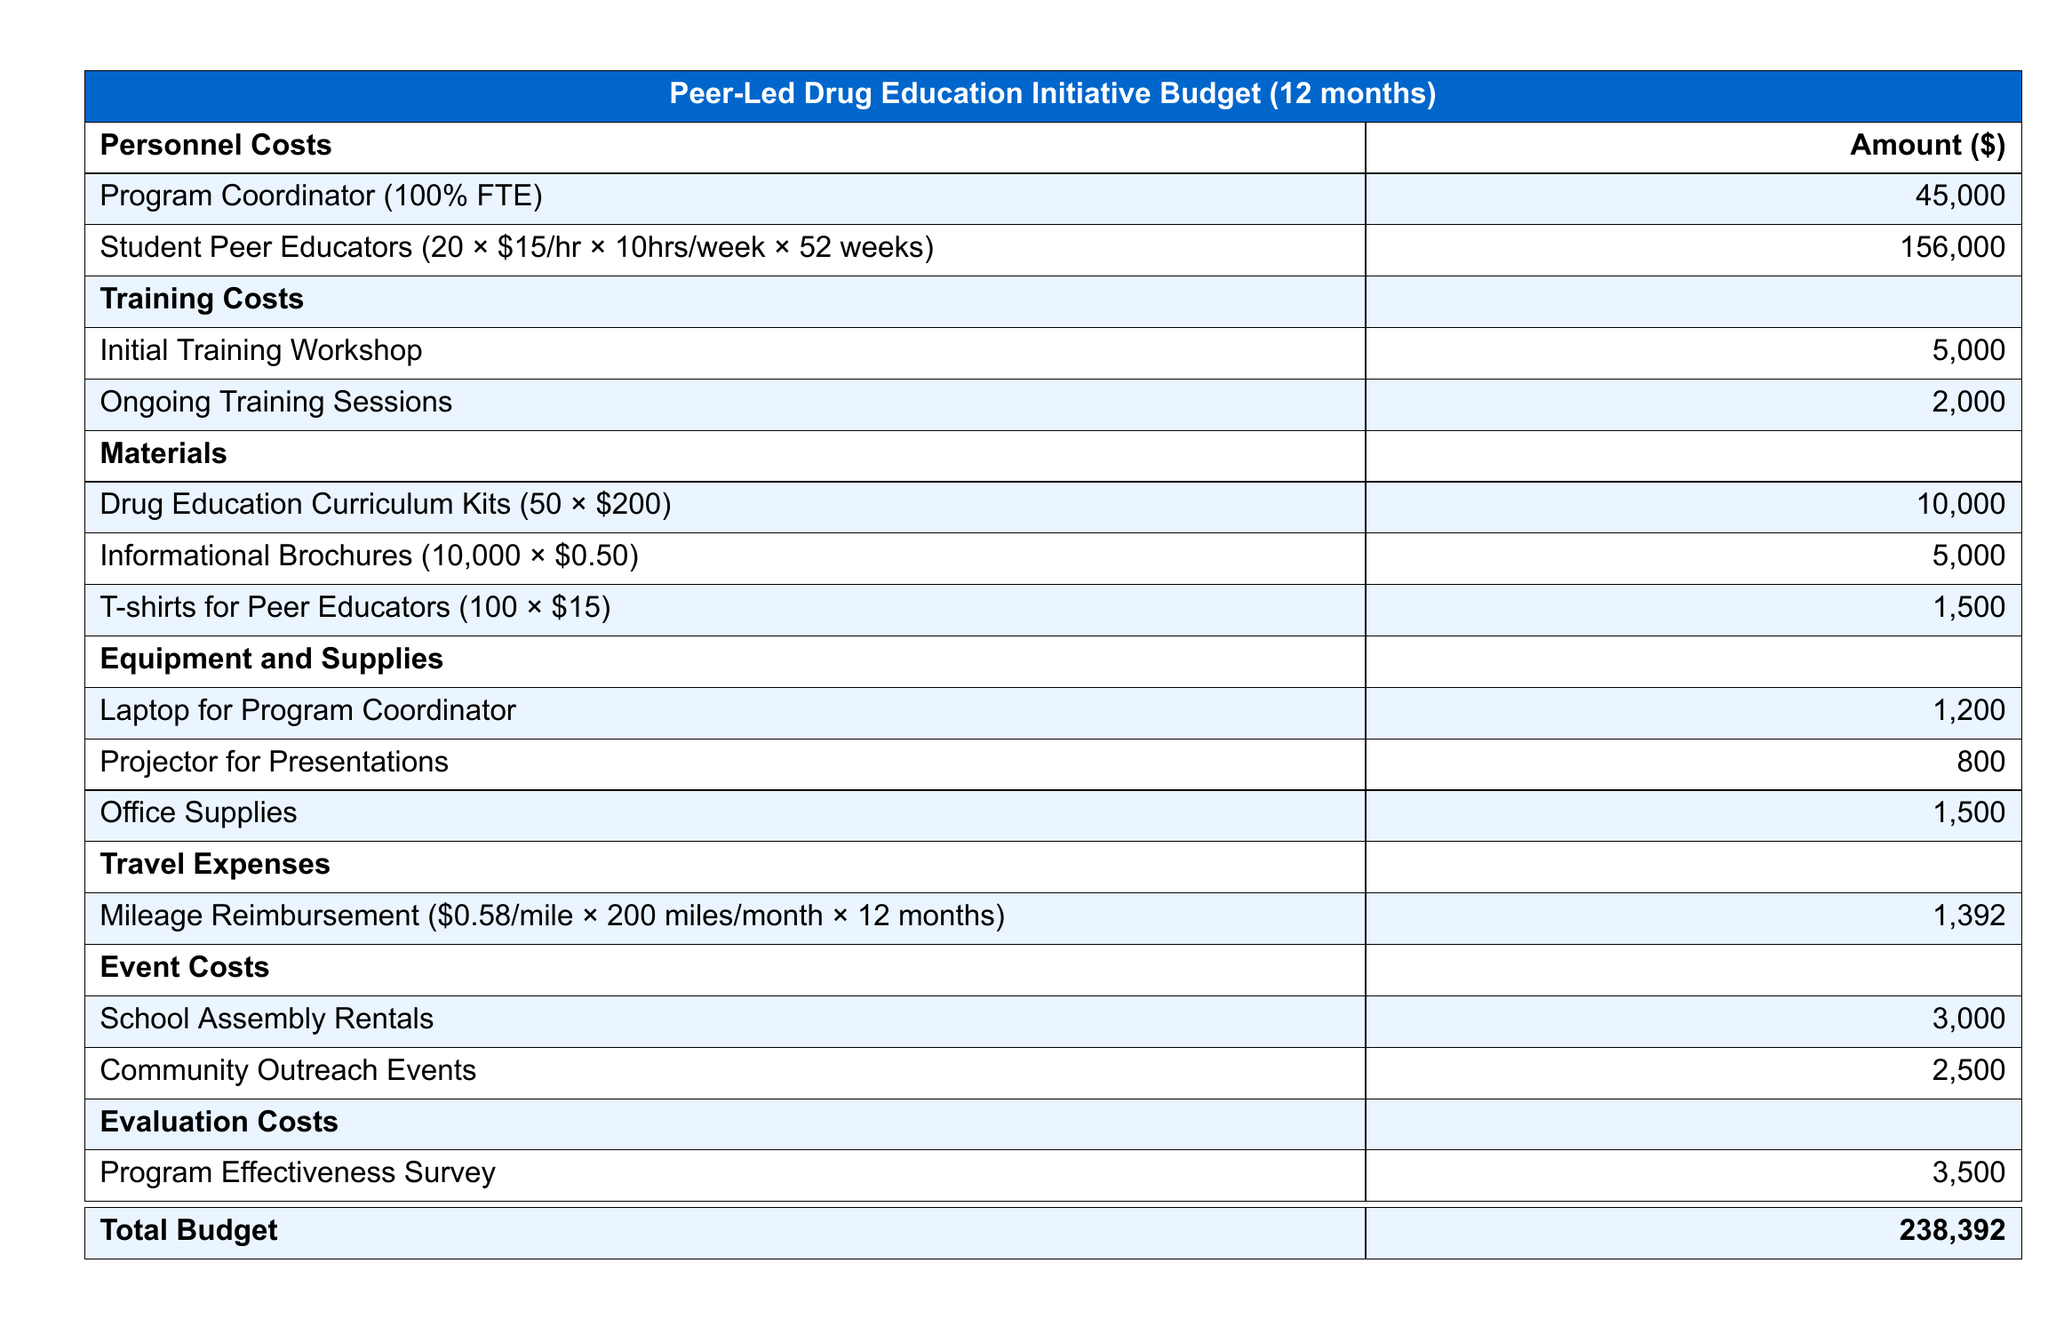What is the total budget? The total budget is listed at the bottom of the document, aggregating all costs.
Answer: 238,392 How much are the materials for drug education curriculum kits? The document specifies the cost for curriculum kits, calculated as the number of kits times the price per kit.
Answer: 10,000 What is the cost per hour for Student Peer Educators? The budget indicates the hourly rate for Student Peer Educators in the personnel costs section.
Answer: 15 How many Student Peer Educators are included in the budget? The document states the total number of Student Peer Educators as part of the personnel costs.
Answer: 20 What type of expenses do the travel costs cover? Travel expenses are described in the document, detailing the nature of these expenses related to program activities.
Answer: Mileage Reimbursement What is the amount allocated for ongoing training sessions? The budget lists the specific amount dedicated to ongoing training sessions under training costs.
Answer: 2,000 What is included in the evaluation costs? The evaluation costs are described in the document, referring specifically to a method used for assessing the program.
Answer: Program Effectiveness Survey What is the amount budgeted for community outreach events? The document specifies an allocation for community outreach activities under event costs.
Answer: 2,500 How much is allocated for the Program Coordinator's salary? The salary for the Program Coordinator is listed explicitly under personnel costs in the document.
Answer: 45,000 